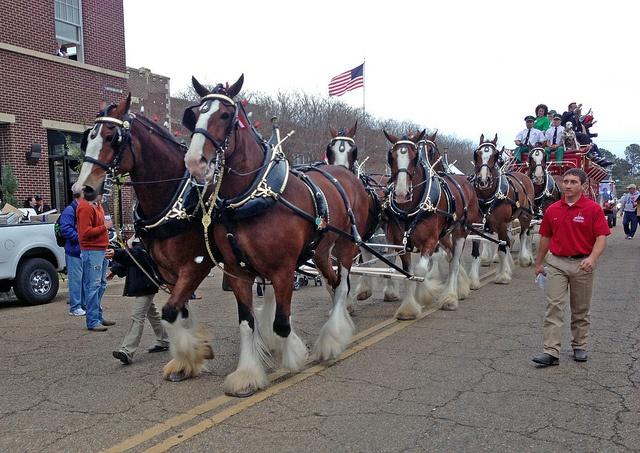Describe the objects in this image and their specific colors. I can see horse in brown, black, gray, maroon, and darkgray tones, horse in brown, black, gray, maroon, and darkgray tones, horse in brown, black, gray, darkgray, and maroon tones, people in brown, gray, and maroon tones, and horse in brown, black, gray, darkgray, and maroon tones in this image. 